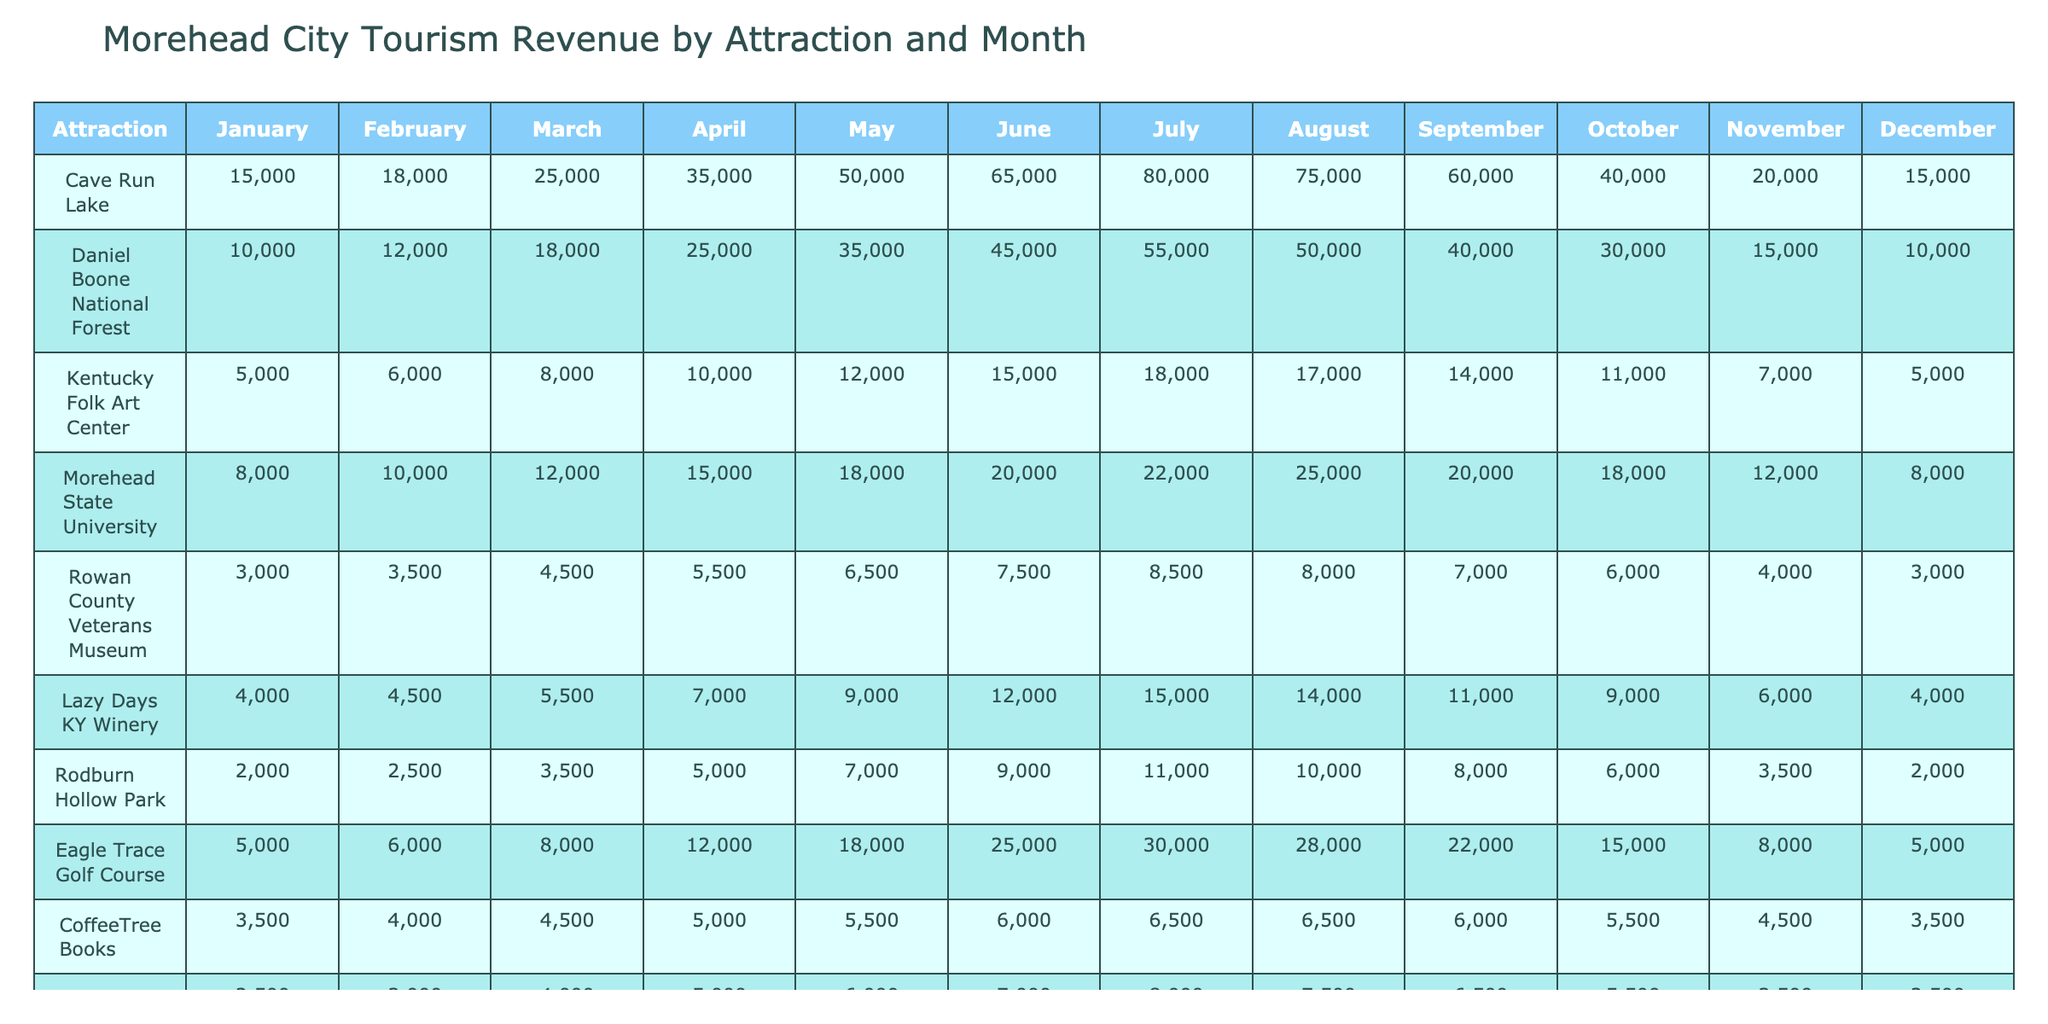What was the highest tourism revenue for Cave Run Lake, and in which month did it occur? The highest tourism revenue for Cave Run Lake was $80,000 in July, as indicated by the table.
Answer: $80,000 in July Which attraction had the lowest tourism revenue in November? The attraction with the lowest tourism revenue in November was the Rowan County Veterans Museum, with a revenue of $3,000.
Answer: $3,000 for Rowan County Veterans Museum What is the total revenue generated by the Kentucky Folk Art Center over the year? Adding up the monthly revenues for the Kentucky Folk Art Center gives us $5,000 + $6,000 + $8,000 + $10,000 + $12,000 + $15,000 + $18,000 + $17,000 + $14,000 + $11,000 + $7,000 + $5,000, which sums to $120,000.
Answer: $120,000 How much more revenue did Eagle Trace Golf Course generate in June compared to the Rowan County Veterans Museum? Eagle Trace Golf Course generated $25,000 in June, while Rowan County Veterans Museum generated $7,500. The difference is $25,000 - $7,500 = $17,500.
Answer: $17,500 Which month saw the highest average revenue across all attractions, and what was that average? To find the highest average revenue, we can calculate the total revenue for each month and divide by the number of attractions. After the calculations, we find that August had the highest average with $23,583.33.
Answer: August with $23,583.33 Did Morehead State University consistently increase its revenue from January to July? Looking at the revenues for Morehead State University: $8,000 (January), $10,000 (February), $12,000 (March), $15,000 (April), $18,000 (May), $20,000 (June), and $22,000 (July), we see that the values are indeed consistently increasing each month. Therefore, the statement is true.
Answer: Yes What is the total revenue generated by all attractions combined in May? Summing the revenues from all attractions in May: $50,000 (Cave Run Lake) + $35,000 (Daniel Boone National Forest) + $12,000 (Kentucky Folk Art Center) + $18,000 (Morehead State University) + $6,500 (Rowan County Veterans Museum) + $9,000 (Lazy Days KY Winery) + $7,000 (Rodburn Hollow Park) + $18,000 (Eagle Trace Golf Course) + $5,500 (CoffeeTree Books) + $6,000 (Morehead History & Railroad Museum) gives a total of $338,000.
Answer: $338,000 Which attraction experienced the smallest revenue increase from June to July? Looking at the revenues from June to July: Cave Run Lake ($80,000 - $65,000 = $15,000), Daniel Boone National Forest ($55,000 - $45,000 = $10,000), Kentucky Folk Art Center ($18,000 - $15,000 = $3,000), Morehead State University ($22,000 - $20,000 = $2,000), and others, we see that Morehead State University experienced the smallest increase of $2,000.
Answer: Morehead State University with $2,000 increase What was the total revenue in December compared to January? In December, the total revenue was calculated as $15,000 (Cave Run Lake) + $10,000 (Daniel Boone National Forest) + $5,000 (Kentucky Folk Art Center) + $8,000 (Morehead State University) + $3,000 (Rowan County Veterans Museum) + $4,000 (Lazy Days KY Winery) + $2,000 (Rodburn Hollow Park) + $5,000 (Eagle Trace Golf Course) + $3,500 (CoffeeTree Books) + $2,500 (Morehead History & Railroad Museum), which totaled $62,000. In January, the total was $15,000 + $10,000 + $5,000 + $8,000 + $3,000 + $4,000 + $2,000 + $5,000 + $3,500 + $2,500, totaling $53,000. Therefore, December had $9,000 more in revenue than January.
Answer: December had $9,000 more than January 